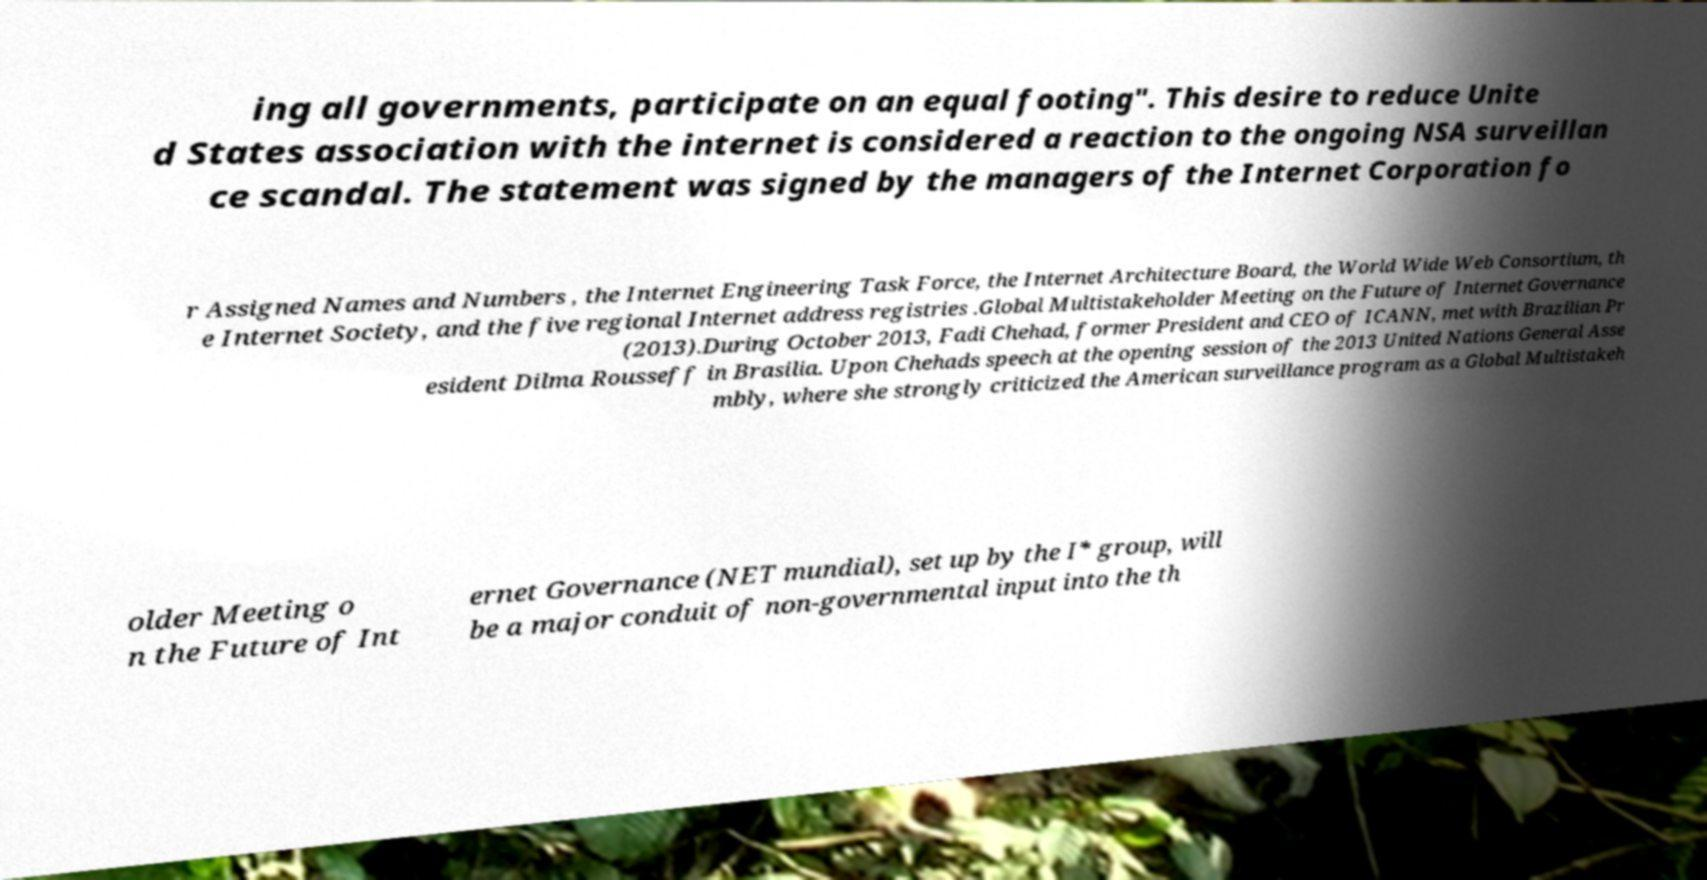Can you read and provide the text displayed in the image?This photo seems to have some interesting text. Can you extract and type it out for me? ing all governments, participate on an equal footing". This desire to reduce Unite d States association with the internet is considered a reaction to the ongoing NSA surveillan ce scandal. The statement was signed by the managers of the Internet Corporation fo r Assigned Names and Numbers , the Internet Engineering Task Force, the Internet Architecture Board, the World Wide Web Consortium, th e Internet Society, and the five regional Internet address registries .Global Multistakeholder Meeting on the Future of Internet Governance (2013).During October 2013, Fadi Chehad, former President and CEO of ICANN, met with Brazilian Pr esident Dilma Rousseff in Brasilia. Upon Chehads speech at the opening session of the 2013 United Nations General Asse mbly, where she strongly criticized the American surveillance program as a Global Multistakeh older Meeting o n the Future of Int ernet Governance (NET mundial), set up by the I* group, will be a major conduit of non-governmental input into the th 